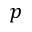<formula> <loc_0><loc_0><loc_500><loc_500>p</formula> 